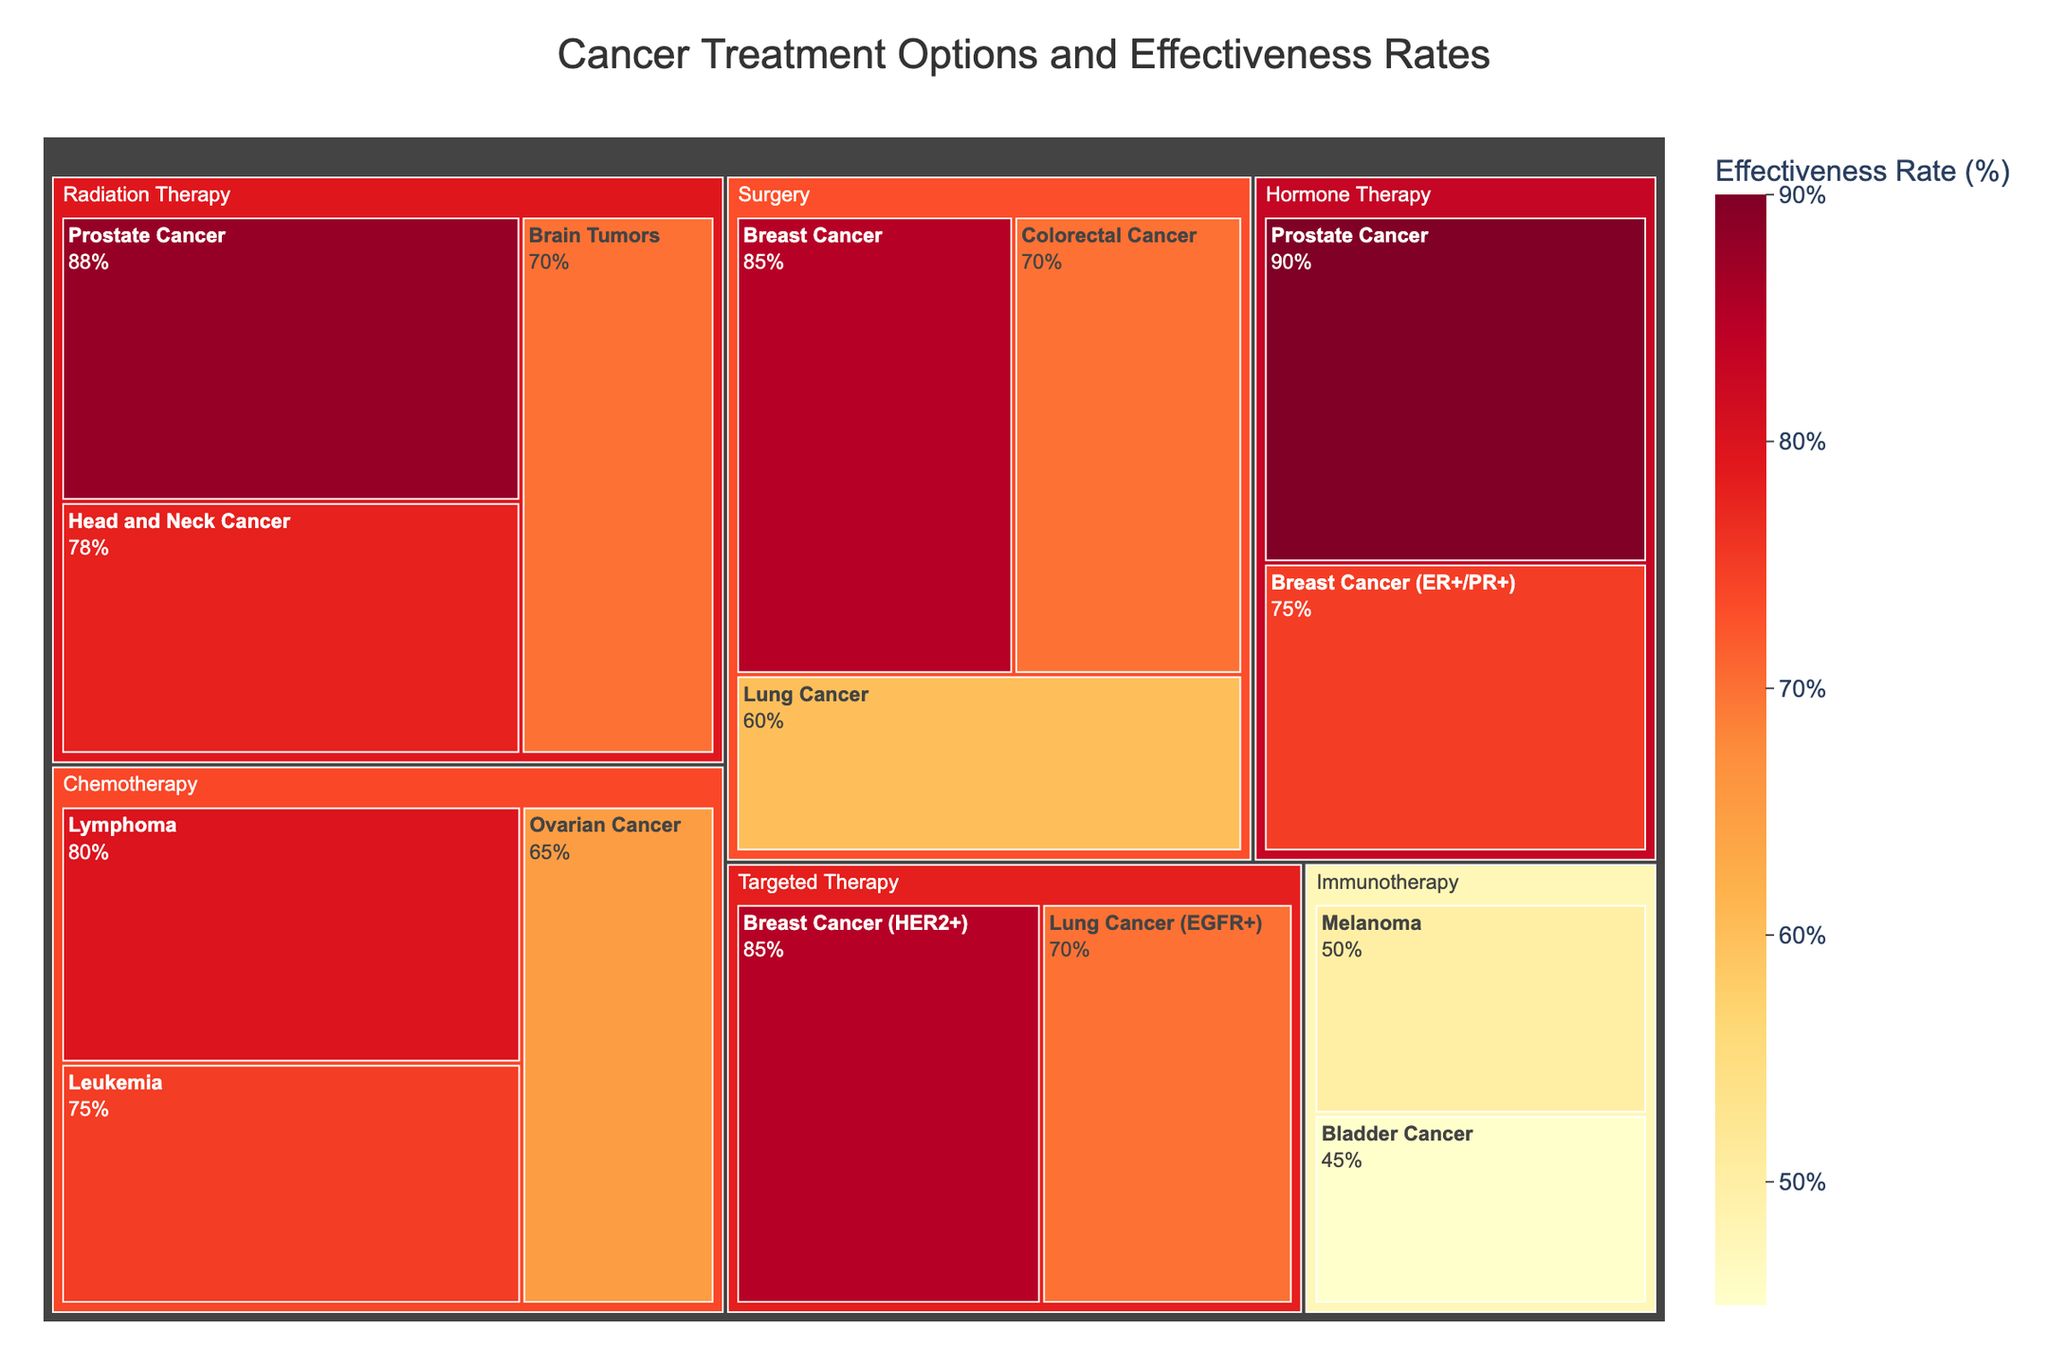Who has the highest effectiveness rate among all cancer treatments? The label with the highest effectiveness rate in the treemap refers to Hormone Therapy for Prostate Cancer, with a rate of 90%.
Answer: Hormone Therapy for Prostate Cancer Which treatment option is most effective for Colorectal Cancer? The treemap shows a block for Surgery related to Colorectal Cancer. The effectiveness rate mentioned is 70%.
Answer: Surgery Which type of cancer has the lowest effectiveness rate for Immunotherapy? The Immunotherapy section contains two types of cancer: Melanoma and Bladder Cancer. Among these, Bladder Cancer has the lower effectiveness rate of 45%.
Answer: Bladder Cancer Among the treatment options provided, which one has the highest effectiveness rate for Breast Cancer? For Breast Cancer, the treemap shows multiple treatment options: Surgery, Targeted Therapy and Hormone Therapy. Among these, Targeted Therapy and Surgery both have an effectiveness rate of 85%, which is the highest.
Answer: Targeted Therapy and Surgery Which treatment type shows the overall highest effectiveness rate and what is it? The block for Hormone Therapy related to Prostate Cancer shows the highest overall effectiveness rate of 90%.
Answer: Hormone Therapy for Prostate Cancer, 90% How does the effectiveness of Chemotherapy for Leukemia compare to its effectiveness for Lymphoma? The blocks for Chemotherapy show that Leukemia has an effectiveness rate of 75%, while Lymphoma has a rate of 80%. Therefore, Lymphoma's effectiveness rate is higher.
Answer: Lymphoma is higher What's the total sum of effectiveness rates for the cancers treated by Radiation Therapy? Radiation Therapy is used for Prostate Cancer (88%), Brain Tumors (70%), and Head and Neck Cancer (78%). Summing these rates: 88 + 70 + 78 = 236.
Answer: 236 What is the average effectiveness rate for surgical treatments? The effectiveness rates for Surgery are: Breast Cancer (85%), Lung Cancer (60%), and Colorectal Cancer (70%). The average is calculated as (85 + 60 + 70) / 3 = 71.67%.
Answer: 71.67% Is Hormone Therapy more effective for Breast Cancer or Prostate Cancer? The blocks show that Hormone Therapy for Breast Cancer (ER+/PR+) has an effectiveness rate of 75%, while for Prostate Cancer, it is 90%. So, it is more effective for Prostate Cancer.
Answer: Prostate Cancer 